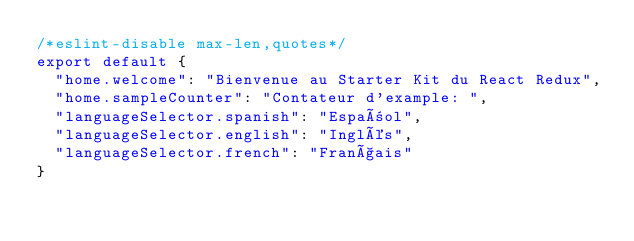<code> <loc_0><loc_0><loc_500><loc_500><_JavaScript_>/*eslint-disable max-len,quotes*/
export default {
  "home.welcome": "Bienvenue au Starter Kit du React Redux",
  "home.sampleCounter": "Contateur d'example: ",
  "languageSelector.spanish": "Español",
  "languageSelector.english": "Inglés",
  "languageSelector.french": "Français"
}

</code> 